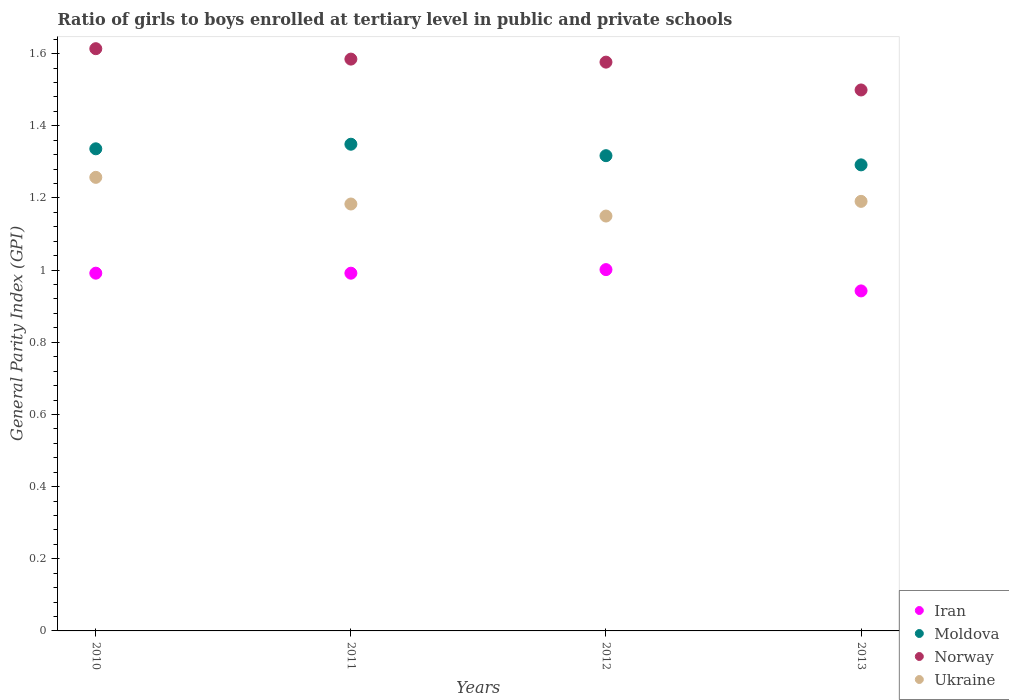How many different coloured dotlines are there?
Ensure brevity in your answer.  4. What is the general parity index in Moldova in 2011?
Offer a very short reply. 1.35. Across all years, what is the maximum general parity index in Ukraine?
Provide a succinct answer. 1.26. Across all years, what is the minimum general parity index in Moldova?
Your answer should be very brief. 1.29. In which year was the general parity index in Ukraine maximum?
Give a very brief answer. 2010. In which year was the general parity index in Moldova minimum?
Ensure brevity in your answer.  2013. What is the total general parity index in Iran in the graph?
Ensure brevity in your answer.  3.93. What is the difference between the general parity index in Moldova in 2010 and that in 2013?
Give a very brief answer. 0.04. What is the difference between the general parity index in Norway in 2013 and the general parity index in Iran in 2010?
Your answer should be compact. 0.51. What is the average general parity index in Iran per year?
Keep it short and to the point. 0.98. In the year 2010, what is the difference between the general parity index in Norway and general parity index in Iran?
Your answer should be compact. 0.62. In how many years, is the general parity index in Moldova greater than 0.8?
Keep it short and to the point. 4. What is the ratio of the general parity index in Moldova in 2011 to that in 2013?
Ensure brevity in your answer.  1.04. Is the difference between the general parity index in Norway in 2011 and 2013 greater than the difference between the general parity index in Iran in 2011 and 2013?
Your answer should be very brief. Yes. What is the difference between the highest and the second highest general parity index in Iran?
Provide a short and direct response. 0.01. What is the difference between the highest and the lowest general parity index in Iran?
Provide a succinct answer. 0.06. In how many years, is the general parity index in Moldova greater than the average general parity index in Moldova taken over all years?
Your answer should be compact. 2. Is it the case that in every year, the sum of the general parity index in Iran and general parity index in Moldova  is greater than the sum of general parity index in Ukraine and general parity index in Norway?
Your answer should be very brief. Yes. Is it the case that in every year, the sum of the general parity index in Norway and general parity index in Ukraine  is greater than the general parity index in Moldova?
Your answer should be compact. Yes. Is the general parity index in Iran strictly greater than the general parity index in Norway over the years?
Ensure brevity in your answer.  No. Is the general parity index in Norway strictly less than the general parity index in Moldova over the years?
Offer a very short reply. No. How many dotlines are there?
Offer a terse response. 4. Are the values on the major ticks of Y-axis written in scientific E-notation?
Provide a short and direct response. No. Does the graph contain grids?
Your answer should be compact. No. Where does the legend appear in the graph?
Offer a terse response. Bottom right. How many legend labels are there?
Your answer should be very brief. 4. What is the title of the graph?
Give a very brief answer. Ratio of girls to boys enrolled at tertiary level in public and private schools. Does "Tajikistan" appear as one of the legend labels in the graph?
Make the answer very short. No. What is the label or title of the X-axis?
Your response must be concise. Years. What is the label or title of the Y-axis?
Keep it short and to the point. General Parity Index (GPI). What is the General Parity Index (GPI) of Iran in 2010?
Provide a short and direct response. 0.99. What is the General Parity Index (GPI) of Moldova in 2010?
Make the answer very short. 1.34. What is the General Parity Index (GPI) in Norway in 2010?
Keep it short and to the point. 1.61. What is the General Parity Index (GPI) of Ukraine in 2010?
Your answer should be very brief. 1.26. What is the General Parity Index (GPI) of Iran in 2011?
Keep it short and to the point. 0.99. What is the General Parity Index (GPI) of Moldova in 2011?
Give a very brief answer. 1.35. What is the General Parity Index (GPI) in Norway in 2011?
Provide a short and direct response. 1.58. What is the General Parity Index (GPI) of Ukraine in 2011?
Your response must be concise. 1.18. What is the General Parity Index (GPI) of Iran in 2012?
Your answer should be compact. 1. What is the General Parity Index (GPI) in Moldova in 2012?
Offer a terse response. 1.32. What is the General Parity Index (GPI) in Norway in 2012?
Give a very brief answer. 1.58. What is the General Parity Index (GPI) in Ukraine in 2012?
Offer a terse response. 1.15. What is the General Parity Index (GPI) of Iran in 2013?
Your answer should be compact. 0.94. What is the General Parity Index (GPI) in Moldova in 2013?
Provide a succinct answer. 1.29. What is the General Parity Index (GPI) of Norway in 2013?
Provide a succinct answer. 1.5. What is the General Parity Index (GPI) in Ukraine in 2013?
Offer a terse response. 1.19. Across all years, what is the maximum General Parity Index (GPI) of Iran?
Provide a succinct answer. 1. Across all years, what is the maximum General Parity Index (GPI) in Moldova?
Your answer should be very brief. 1.35. Across all years, what is the maximum General Parity Index (GPI) of Norway?
Your answer should be very brief. 1.61. Across all years, what is the maximum General Parity Index (GPI) of Ukraine?
Make the answer very short. 1.26. Across all years, what is the minimum General Parity Index (GPI) of Iran?
Provide a short and direct response. 0.94. Across all years, what is the minimum General Parity Index (GPI) in Moldova?
Your response must be concise. 1.29. Across all years, what is the minimum General Parity Index (GPI) in Norway?
Give a very brief answer. 1.5. Across all years, what is the minimum General Parity Index (GPI) of Ukraine?
Provide a short and direct response. 1.15. What is the total General Parity Index (GPI) of Iran in the graph?
Your answer should be very brief. 3.93. What is the total General Parity Index (GPI) in Moldova in the graph?
Ensure brevity in your answer.  5.29. What is the total General Parity Index (GPI) in Norway in the graph?
Provide a succinct answer. 6.27. What is the total General Parity Index (GPI) in Ukraine in the graph?
Offer a terse response. 4.78. What is the difference between the General Parity Index (GPI) of Iran in 2010 and that in 2011?
Offer a very short reply. 0. What is the difference between the General Parity Index (GPI) of Moldova in 2010 and that in 2011?
Your response must be concise. -0.01. What is the difference between the General Parity Index (GPI) in Norway in 2010 and that in 2011?
Give a very brief answer. 0.03. What is the difference between the General Parity Index (GPI) in Ukraine in 2010 and that in 2011?
Offer a very short reply. 0.07. What is the difference between the General Parity Index (GPI) in Iran in 2010 and that in 2012?
Offer a terse response. -0.01. What is the difference between the General Parity Index (GPI) of Moldova in 2010 and that in 2012?
Your answer should be compact. 0.02. What is the difference between the General Parity Index (GPI) in Norway in 2010 and that in 2012?
Provide a short and direct response. 0.04. What is the difference between the General Parity Index (GPI) in Ukraine in 2010 and that in 2012?
Your response must be concise. 0.11. What is the difference between the General Parity Index (GPI) of Iran in 2010 and that in 2013?
Your answer should be compact. 0.05. What is the difference between the General Parity Index (GPI) of Moldova in 2010 and that in 2013?
Your answer should be compact. 0.04. What is the difference between the General Parity Index (GPI) of Norway in 2010 and that in 2013?
Your answer should be very brief. 0.11. What is the difference between the General Parity Index (GPI) of Ukraine in 2010 and that in 2013?
Your answer should be compact. 0.07. What is the difference between the General Parity Index (GPI) in Iran in 2011 and that in 2012?
Keep it short and to the point. -0.01. What is the difference between the General Parity Index (GPI) in Moldova in 2011 and that in 2012?
Provide a short and direct response. 0.03. What is the difference between the General Parity Index (GPI) of Norway in 2011 and that in 2012?
Keep it short and to the point. 0.01. What is the difference between the General Parity Index (GPI) of Ukraine in 2011 and that in 2012?
Offer a very short reply. 0.03. What is the difference between the General Parity Index (GPI) of Iran in 2011 and that in 2013?
Provide a short and direct response. 0.05. What is the difference between the General Parity Index (GPI) in Moldova in 2011 and that in 2013?
Make the answer very short. 0.06. What is the difference between the General Parity Index (GPI) of Norway in 2011 and that in 2013?
Keep it short and to the point. 0.09. What is the difference between the General Parity Index (GPI) of Ukraine in 2011 and that in 2013?
Offer a terse response. -0.01. What is the difference between the General Parity Index (GPI) of Iran in 2012 and that in 2013?
Your response must be concise. 0.06. What is the difference between the General Parity Index (GPI) of Moldova in 2012 and that in 2013?
Give a very brief answer. 0.03. What is the difference between the General Parity Index (GPI) of Norway in 2012 and that in 2013?
Your answer should be compact. 0.08. What is the difference between the General Parity Index (GPI) in Ukraine in 2012 and that in 2013?
Your response must be concise. -0.04. What is the difference between the General Parity Index (GPI) of Iran in 2010 and the General Parity Index (GPI) of Moldova in 2011?
Give a very brief answer. -0.36. What is the difference between the General Parity Index (GPI) of Iran in 2010 and the General Parity Index (GPI) of Norway in 2011?
Provide a succinct answer. -0.59. What is the difference between the General Parity Index (GPI) in Iran in 2010 and the General Parity Index (GPI) in Ukraine in 2011?
Give a very brief answer. -0.19. What is the difference between the General Parity Index (GPI) of Moldova in 2010 and the General Parity Index (GPI) of Norway in 2011?
Make the answer very short. -0.25. What is the difference between the General Parity Index (GPI) in Moldova in 2010 and the General Parity Index (GPI) in Ukraine in 2011?
Your response must be concise. 0.15. What is the difference between the General Parity Index (GPI) in Norway in 2010 and the General Parity Index (GPI) in Ukraine in 2011?
Your response must be concise. 0.43. What is the difference between the General Parity Index (GPI) in Iran in 2010 and the General Parity Index (GPI) in Moldova in 2012?
Offer a terse response. -0.33. What is the difference between the General Parity Index (GPI) of Iran in 2010 and the General Parity Index (GPI) of Norway in 2012?
Offer a terse response. -0.58. What is the difference between the General Parity Index (GPI) in Iran in 2010 and the General Parity Index (GPI) in Ukraine in 2012?
Your answer should be compact. -0.16. What is the difference between the General Parity Index (GPI) of Moldova in 2010 and the General Parity Index (GPI) of Norway in 2012?
Make the answer very short. -0.24. What is the difference between the General Parity Index (GPI) of Moldova in 2010 and the General Parity Index (GPI) of Ukraine in 2012?
Your answer should be compact. 0.19. What is the difference between the General Parity Index (GPI) of Norway in 2010 and the General Parity Index (GPI) of Ukraine in 2012?
Give a very brief answer. 0.46. What is the difference between the General Parity Index (GPI) in Iran in 2010 and the General Parity Index (GPI) in Moldova in 2013?
Provide a short and direct response. -0.3. What is the difference between the General Parity Index (GPI) of Iran in 2010 and the General Parity Index (GPI) of Norway in 2013?
Keep it short and to the point. -0.51. What is the difference between the General Parity Index (GPI) of Iran in 2010 and the General Parity Index (GPI) of Ukraine in 2013?
Ensure brevity in your answer.  -0.2. What is the difference between the General Parity Index (GPI) of Moldova in 2010 and the General Parity Index (GPI) of Norway in 2013?
Your response must be concise. -0.16. What is the difference between the General Parity Index (GPI) of Moldova in 2010 and the General Parity Index (GPI) of Ukraine in 2013?
Offer a terse response. 0.15. What is the difference between the General Parity Index (GPI) in Norway in 2010 and the General Parity Index (GPI) in Ukraine in 2013?
Provide a succinct answer. 0.42. What is the difference between the General Parity Index (GPI) of Iran in 2011 and the General Parity Index (GPI) of Moldova in 2012?
Provide a succinct answer. -0.33. What is the difference between the General Parity Index (GPI) of Iran in 2011 and the General Parity Index (GPI) of Norway in 2012?
Offer a terse response. -0.58. What is the difference between the General Parity Index (GPI) in Iran in 2011 and the General Parity Index (GPI) in Ukraine in 2012?
Keep it short and to the point. -0.16. What is the difference between the General Parity Index (GPI) of Moldova in 2011 and the General Parity Index (GPI) of Norway in 2012?
Make the answer very short. -0.23. What is the difference between the General Parity Index (GPI) of Moldova in 2011 and the General Parity Index (GPI) of Ukraine in 2012?
Your response must be concise. 0.2. What is the difference between the General Parity Index (GPI) in Norway in 2011 and the General Parity Index (GPI) in Ukraine in 2012?
Give a very brief answer. 0.43. What is the difference between the General Parity Index (GPI) in Iran in 2011 and the General Parity Index (GPI) in Moldova in 2013?
Your answer should be compact. -0.3. What is the difference between the General Parity Index (GPI) of Iran in 2011 and the General Parity Index (GPI) of Norway in 2013?
Provide a succinct answer. -0.51. What is the difference between the General Parity Index (GPI) in Iran in 2011 and the General Parity Index (GPI) in Ukraine in 2013?
Your answer should be very brief. -0.2. What is the difference between the General Parity Index (GPI) of Moldova in 2011 and the General Parity Index (GPI) of Norway in 2013?
Offer a very short reply. -0.15. What is the difference between the General Parity Index (GPI) of Moldova in 2011 and the General Parity Index (GPI) of Ukraine in 2013?
Ensure brevity in your answer.  0.16. What is the difference between the General Parity Index (GPI) in Norway in 2011 and the General Parity Index (GPI) in Ukraine in 2013?
Provide a short and direct response. 0.39. What is the difference between the General Parity Index (GPI) in Iran in 2012 and the General Parity Index (GPI) in Moldova in 2013?
Your response must be concise. -0.29. What is the difference between the General Parity Index (GPI) of Iran in 2012 and the General Parity Index (GPI) of Norway in 2013?
Keep it short and to the point. -0.5. What is the difference between the General Parity Index (GPI) of Iran in 2012 and the General Parity Index (GPI) of Ukraine in 2013?
Provide a short and direct response. -0.19. What is the difference between the General Parity Index (GPI) of Moldova in 2012 and the General Parity Index (GPI) of Norway in 2013?
Offer a very short reply. -0.18. What is the difference between the General Parity Index (GPI) in Moldova in 2012 and the General Parity Index (GPI) in Ukraine in 2013?
Ensure brevity in your answer.  0.13. What is the difference between the General Parity Index (GPI) of Norway in 2012 and the General Parity Index (GPI) of Ukraine in 2013?
Offer a very short reply. 0.39. What is the average General Parity Index (GPI) in Iran per year?
Give a very brief answer. 0.98. What is the average General Parity Index (GPI) in Moldova per year?
Your answer should be very brief. 1.32. What is the average General Parity Index (GPI) in Norway per year?
Keep it short and to the point. 1.57. What is the average General Parity Index (GPI) of Ukraine per year?
Provide a short and direct response. 1.2. In the year 2010, what is the difference between the General Parity Index (GPI) of Iran and General Parity Index (GPI) of Moldova?
Your response must be concise. -0.34. In the year 2010, what is the difference between the General Parity Index (GPI) in Iran and General Parity Index (GPI) in Norway?
Your response must be concise. -0.62. In the year 2010, what is the difference between the General Parity Index (GPI) in Iran and General Parity Index (GPI) in Ukraine?
Ensure brevity in your answer.  -0.27. In the year 2010, what is the difference between the General Parity Index (GPI) in Moldova and General Parity Index (GPI) in Norway?
Provide a short and direct response. -0.28. In the year 2010, what is the difference between the General Parity Index (GPI) of Moldova and General Parity Index (GPI) of Ukraine?
Your answer should be very brief. 0.08. In the year 2010, what is the difference between the General Parity Index (GPI) of Norway and General Parity Index (GPI) of Ukraine?
Keep it short and to the point. 0.36. In the year 2011, what is the difference between the General Parity Index (GPI) of Iran and General Parity Index (GPI) of Moldova?
Your answer should be compact. -0.36. In the year 2011, what is the difference between the General Parity Index (GPI) of Iran and General Parity Index (GPI) of Norway?
Your answer should be very brief. -0.59. In the year 2011, what is the difference between the General Parity Index (GPI) of Iran and General Parity Index (GPI) of Ukraine?
Your response must be concise. -0.19. In the year 2011, what is the difference between the General Parity Index (GPI) in Moldova and General Parity Index (GPI) in Norway?
Your answer should be compact. -0.24. In the year 2011, what is the difference between the General Parity Index (GPI) of Moldova and General Parity Index (GPI) of Ukraine?
Your answer should be compact. 0.17. In the year 2011, what is the difference between the General Parity Index (GPI) of Norway and General Parity Index (GPI) of Ukraine?
Offer a very short reply. 0.4. In the year 2012, what is the difference between the General Parity Index (GPI) of Iran and General Parity Index (GPI) of Moldova?
Offer a very short reply. -0.32. In the year 2012, what is the difference between the General Parity Index (GPI) of Iran and General Parity Index (GPI) of Norway?
Offer a terse response. -0.57. In the year 2012, what is the difference between the General Parity Index (GPI) of Iran and General Parity Index (GPI) of Ukraine?
Keep it short and to the point. -0.15. In the year 2012, what is the difference between the General Parity Index (GPI) of Moldova and General Parity Index (GPI) of Norway?
Your response must be concise. -0.26. In the year 2012, what is the difference between the General Parity Index (GPI) of Moldova and General Parity Index (GPI) of Ukraine?
Offer a terse response. 0.17. In the year 2012, what is the difference between the General Parity Index (GPI) of Norway and General Parity Index (GPI) of Ukraine?
Give a very brief answer. 0.43. In the year 2013, what is the difference between the General Parity Index (GPI) of Iran and General Parity Index (GPI) of Moldova?
Your answer should be very brief. -0.35. In the year 2013, what is the difference between the General Parity Index (GPI) of Iran and General Parity Index (GPI) of Norway?
Offer a very short reply. -0.56. In the year 2013, what is the difference between the General Parity Index (GPI) in Iran and General Parity Index (GPI) in Ukraine?
Offer a terse response. -0.25. In the year 2013, what is the difference between the General Parity Index (GPI) of Moldova and General Parity Index (GPI) of Norway?
Offer a very short reply. -0.21. In the year 2013, what is the difference between the General Parity Index (GPI) in Moldova and General Parity Index (GPI) in Ukraine?
Offer a very short reply. 0.1. In the year 2013, what is the difference between the General Parity Index (GPI) of Norway and General Parity Index (GPI) of Ukraine?
Provide a short and direct response. 0.31. What is the ratio of the General Parity Index (GPI) in Iran in 2010 to that in 2011?
Make the answer very short. 1. What is the ratio of the General Parity Index (GPI) of Moldova in 2010 to that in 2011?
Ensure brevity in your answer.  0.99. What is the ratio of the General Parity Index (GPI) in Norway in 2010 to that in 2011?
Provide a succinct answer. 1.02. What is the ratio of the General Parity Index (GPI) of Ukraine in 2010 to that in 2011?
Keep it short and to the point. 1.06. What is the ratio of the General Parity Index (GPI) of Iran in 2010 to that in 2012?
Ensure brevity in your answer.  0.99. What is the ratio of the General Parity Index (GPI) in Moldova in 2010 to that in 2012?
Provide a succinct answer. 1.01. What is the ratio of the General Parity Index (GPI) in Norway in 2010 to that in 2012?
Provide a short and direct response. 1.02. What is the ratio of the General Parity Index (GPI) in Ukraine in 2010 to that in 2012?
Provide a succinct answer. 1.09. What is the ratio of the General Parity Index (GPI) of Iran in 2010 to that in 2013?
Make the answer very short. 1.05. What is the ratio of the General Parity Index (GPI) in Moldova in 2010 to that in 2013?
Offer a very short reply. 1.03. What is the ratio of the General Parity Index (GPI) in Norway in 2010 to that in 2013?
Your answer should be very brief. 1.08. What is the ratio of the General Parity Index (GPI) of Ukraine in 2010 to that in 2013?
Provide a succinct answer. 1.06. What is the ratio of the General Parity Index (GPI) of Moldova in 2011 to that in 2012?
Your answer should be very brief. 1.02. What is the ratio of the General Parity Index (GPI) in Norway in 2011 to that in 2012?
Your response must be concise. 1.01. What is the ratio of the General Parity Index (GPI) of Iran in 2011 to that in 2013?
Provide a succinct answer. 1.05. What is the ratio of the General Parity Index (GPI) of Moldova in 2011 to that in 2013?
Your answer should be very brief. 1.04. What is the ratio of the General Parity Index (GPI) in Norway in 2011 to that in 2013?
Give a very brief answer. 1.06. What is the ratio of the General Parity Index (GPI) in Ukraine in 2011 to that in 2013?
Your answer should be very brief. 0.99. What is the ratio of the General Parity Index (GPI) in Iran in 2012 to that in 2013?
Offer a terse response. 1.06. What is the ratio of the General Parity Index (GPI) of Moldova in 2012 to that in 2013?
Provide a succinct answer. 1.02. What is the ratio of the General Parity Index (GPI) in Norway in 2012 to that in 2013?
Ensure brevity in your answer.  1.05. What is the ratio of the General Parity Index (GPI) of Ukraine in 2012 to that in 2013?
Your response must be concise. 0.97. What is the difference between the highest and the second highest General Parity Index (GPI) in Iran?
Ensure brevity in your answer.  0.01. What is the difference between the highest and the second highest General Parity Index (GPI) of Moldova?
Offer a very short reply. 0.01. What is the difference between the highest and the second highest General Parity Index (GPI) of Norway?
Provide a short and direct response. 0.03. What is the difference between the highest and the second highest General Parity Index (GPI) in Ukraine?
Your response must be concise. 0.07. What is the difference between the highest and the lowest General Parity Index (GPI) in Iran?
Make the answer very short. 0.06. What is the difference between the highest and the lowest General Parity Index (GPI) of Moldova?
Your response must be concise. 0.06. What is the difference between the highest and the lowest General Parity Index (GPI) in Norway?
Your answer should be compact. 0.11. What is the difference between the highest and the lowest General Parity Index (GPI) of Ukraine?
Offer a very short reply. 0.11. 